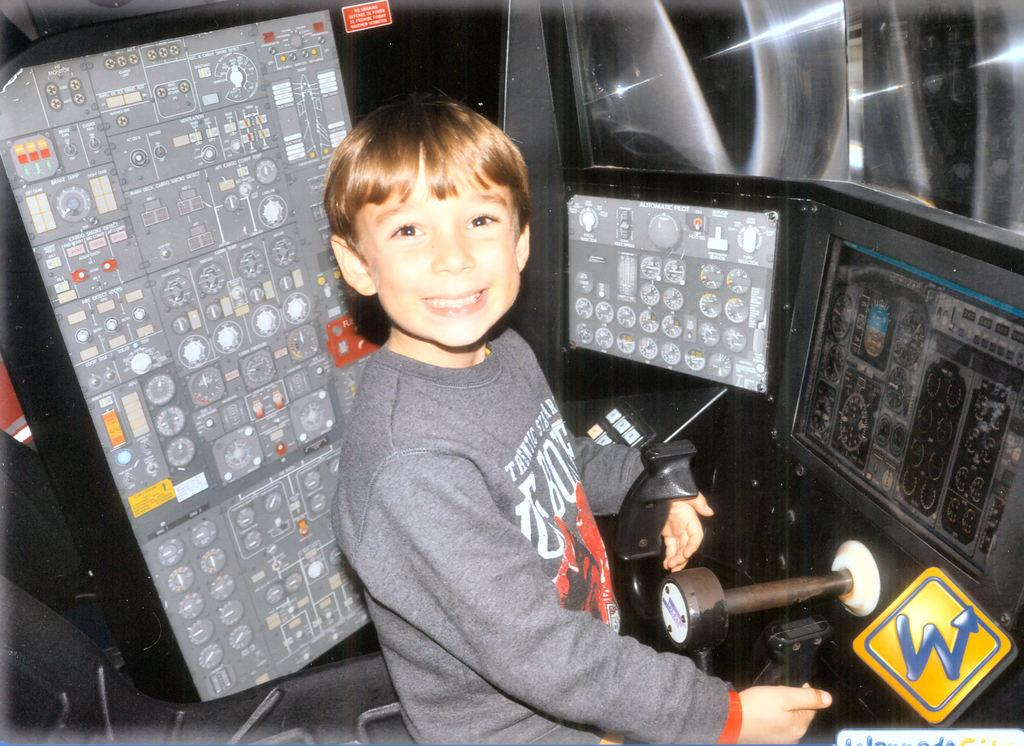<image>
Share a concise interpretation of the image provided. A boy poses to get his picture taken the the cockpit of an airplane at a place named W. 